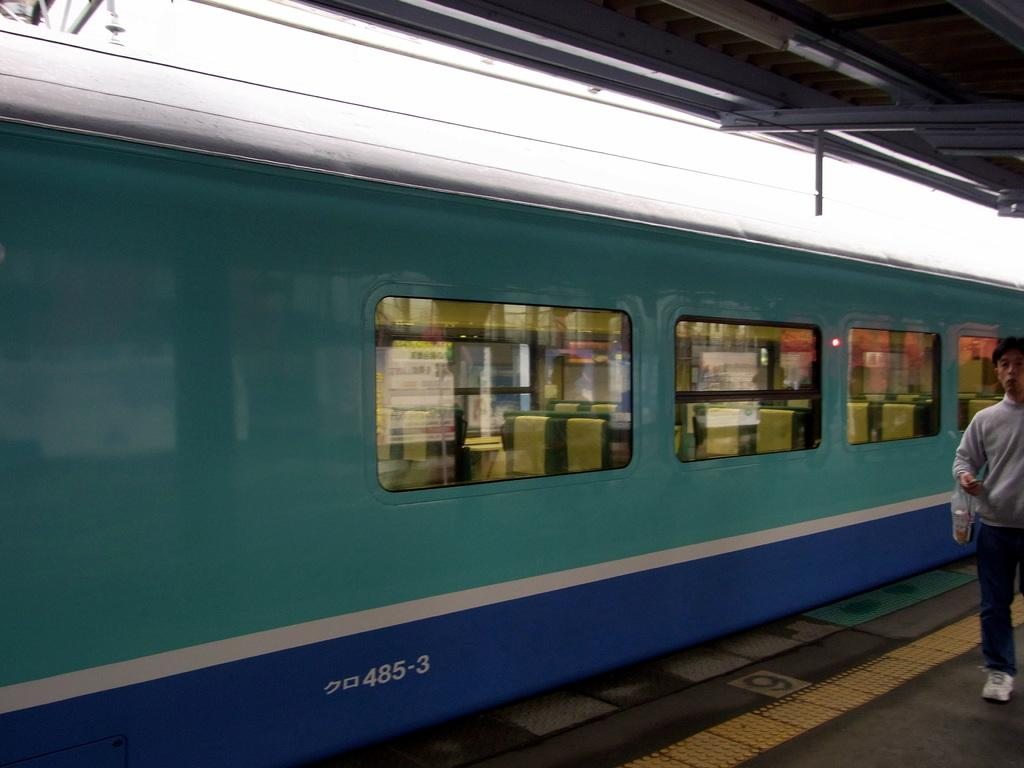What is the main subject of the image? The main subject of the image is a train. What feature can be observed on the train? The train has glass windows. What can be seen through the windows? Seats are visible through the windows. Where is the person in the image located? A person is standing under a shed near the train. What type of chain is hanging from the clock in the image? There is no clock or chain present in the image; it features a train with glass windows and a person standing under a shed. 